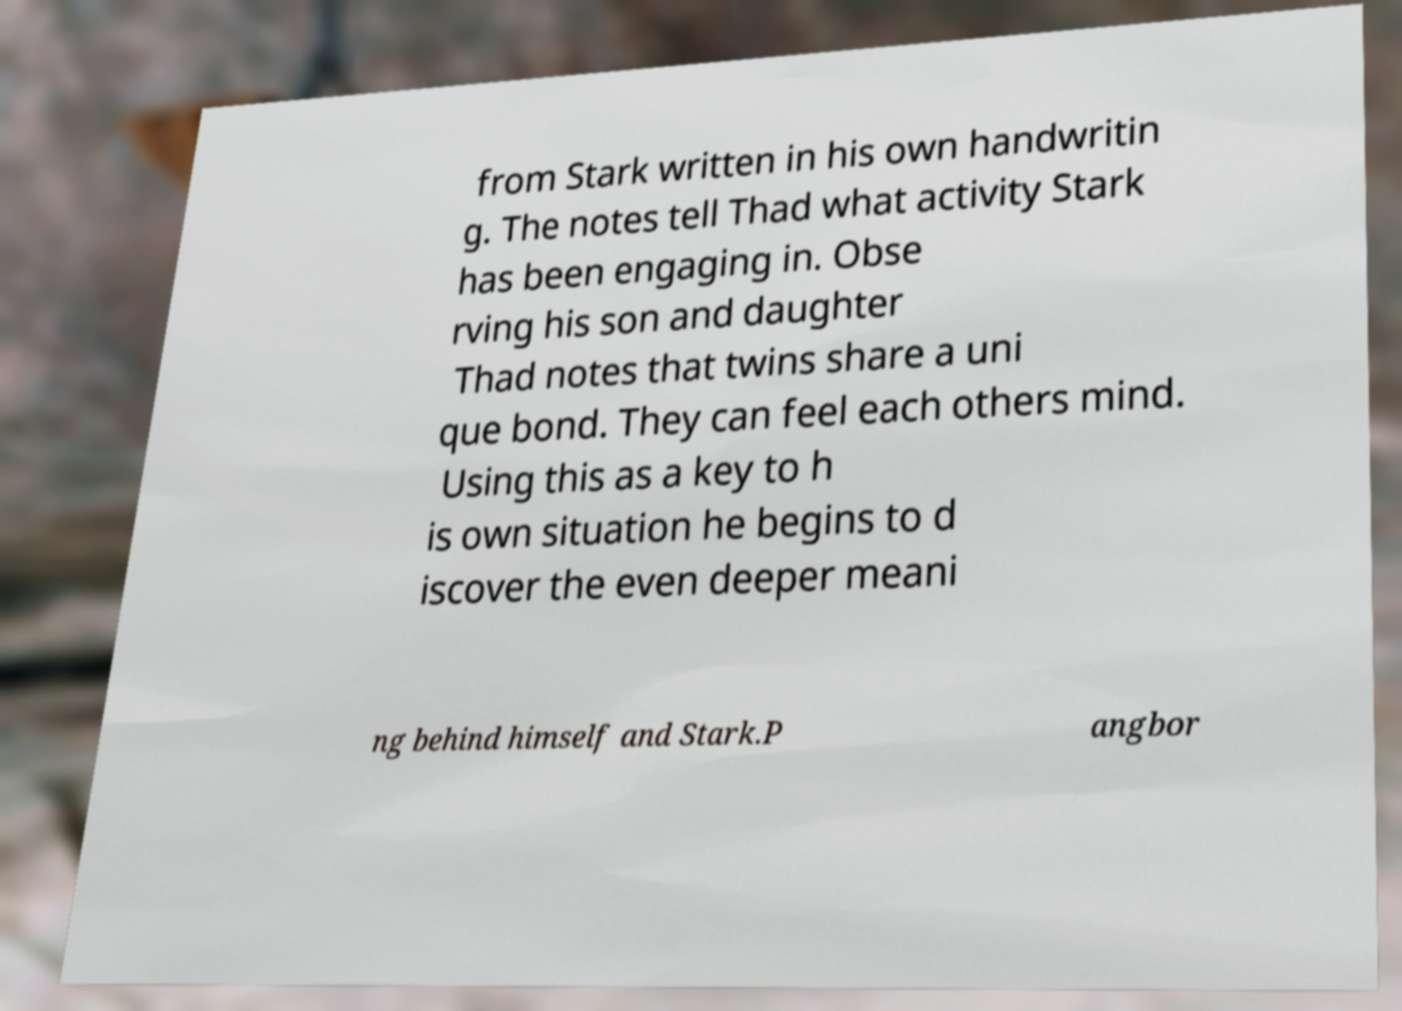Could you extract and type out the text from this image? from Stark written in his own handwritin g. The notes tell Thad what activity Stark has been engaging in. Obse rving his son and daughter Thad notes that twins share a uni que bond. They can feel each others mind. Using this as a key to h is own situation he begins to d iscover the even deeper meani ng behind himself and Stark.P angbor 